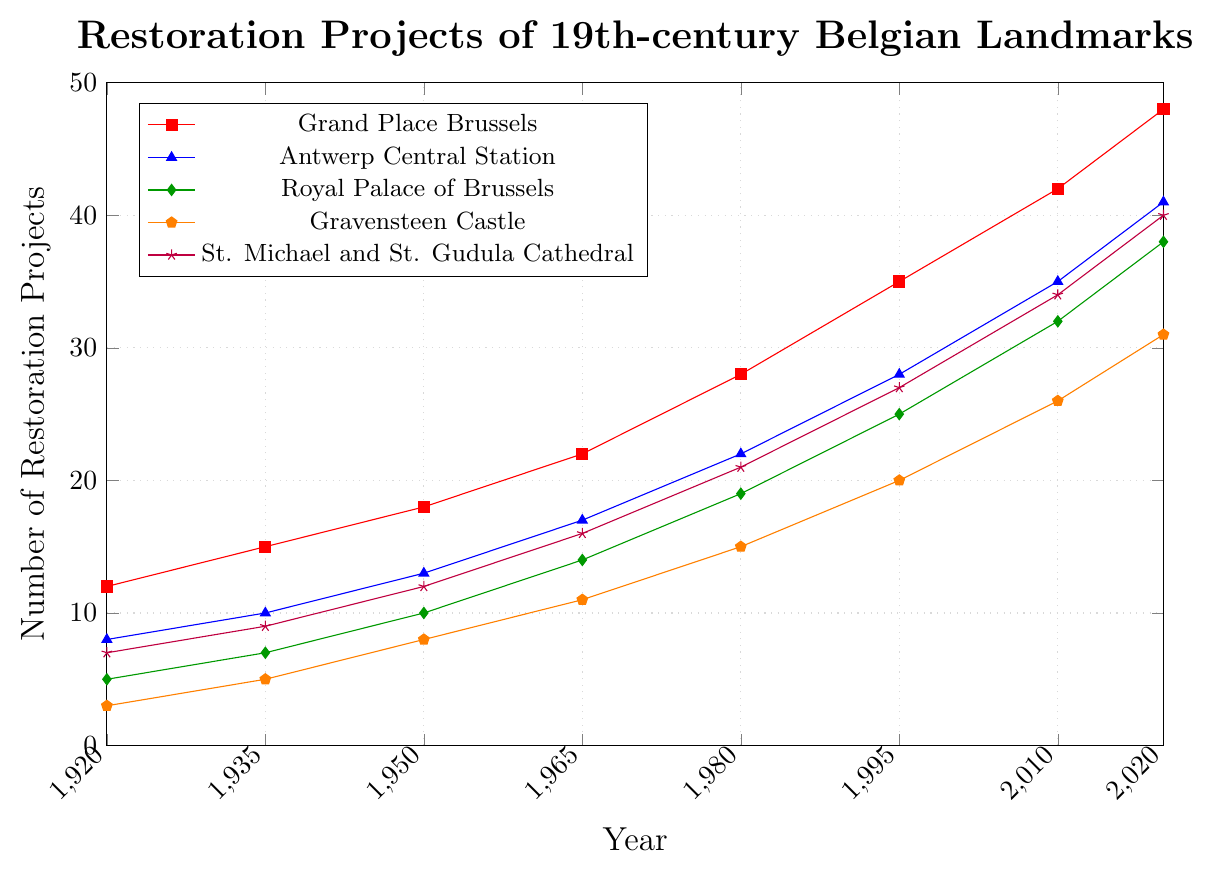Which landmark had the most restoration projects in 2020? By referring to the legend and the year 2020 on the x-axis, we can see the highest point in each color line. The red line representing Grand Place Brussels has the highest value.
Answer: Grand Place Brussels How many more restoration projects were completed in 2020 for Gravensteen Castle compared to 1920? Look at the coordinates for Gravensteen Castle (orange line) at 1920 and 2020. In 1920, it had 3 projects, and in 2020, it had 31 projects. Subtract the two values to find the difference: 31 - 3 = 28.
Answer: 28 What was the average number of restoration projects for St. Michael and St. Gudula Cathedral over the recorded years? The values for St. Michael and St. Gudula Cathedral (purple line) are 7, 9, 12, 16, 21, 27, 34, and 40. Sum these values: 7 + 9 + 12 + 16 + 21 + 27 + 34 + 40 = 166. Divide by the number of years: 166 / 8 = 20.75.
Answer: 20.75 Which two landmarks had the same number of restoration projects in 1950? By checking the y-values at the year 1950 for each landmark, we notice that the Royal Palace of Brussels (green line) and St. Michael and St. Gudula Cathedral (purple line) both had 12 projects.
Answer: Royal Palace of Brussels and St. Michael and St. Gudula Cathedral Did Antwerp Central Station ever surpass Grand Place Brussels in the number of restoration projects? Compare the blue line (Antwerp Central Station) and the red line (Grand Place Brussels) over all the years. Grand Place Brussels consistently has higher values than Antwerp Central Station in every recorded year.
Answer: No What was the rate of increase in restoration projects for the Royal Palace of Brussels from 1920 to 2020? For the Royal Palace of Brussels (green line), the number of projects in 1920 was 5 and in 2020 was 38. The increase is 38 - 5 = 33. The period is 2020 - 1920 = 100 years. The rate of increase is 33 projects per 100 years.
Answer: 0.33 projects per year In which year did the restoration projects for Gravensteen Castle first exceed 10? Check the Gravensteen Castle (orange line). In 1965, the y-value reaches 11, which is the first year it exceeds 10.
Answer: 1965 By how much did the restoration projects for Grand Place Brussels grow between two consecutive time points, 1980 and 1995? For Grand Place Brussels (red line), the number of projects in 1980 was 28 and in 1995 was 35. The growth between these points is 35 - 28 = 7.
Answer: 7 Was there ever a year when the number of restoration projects for St. Michael and St. Gudula Cathedral exactly doubled compared to the year 1920? In 1920, St. Michael and St. Gudula Cathedral had 7 projects (purple line). Doubling 7 gives 14. Check each year; no year matches exactly 14.
Answer: No What is the overall trend observed in the number of restoration projects for all the landmarks? All lines show an upward trend from 1920 to 2020, indicating a general increase in restoration projects over the years.
Answer: Increasing trend 